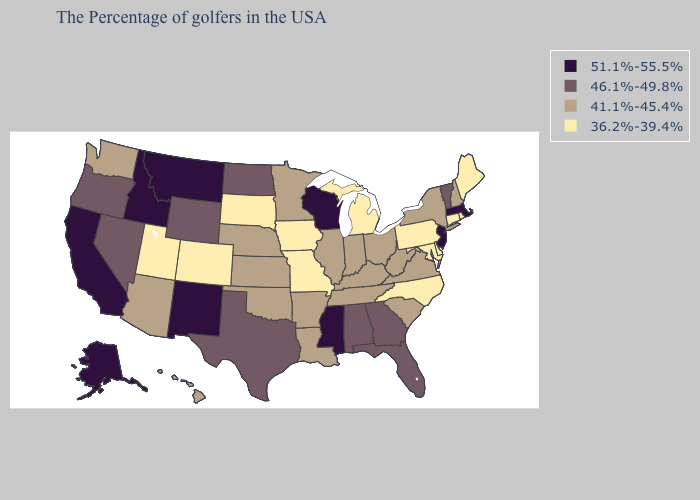What is the highest value in the South ?
Answer briefly. 51.1%-55.5%. Which states hav the highest value in the West?
Answer briefly. New Mexico, Montana, Idaho, California, Alaska. What is the highest value in the USA?
Quick response, please. 51.1%-55.5%. Name the states that have a value in the range 46.1%-49.8%?
Write a very short answer. Vermont, Florida, Georgia, Alabama, Texas, North Dakota, Wyoming, Nevada, Oregon. Which states have the lowest value in the USA?
Be succinct. Maine, Rhode Island, Connecticut, Delaware, Maryland, Pennsylvania, North Carolina, Michigan, Missouri, Iowa, South Dakota, Colorado, Utah. Does Kansas have a higher value than Texas?
Concise answer only. No. Name the states that have a value in the range 46.1%-49.8%?
Answer briefly. Vermont, Florida, Georgia, Alabama, Texas, North Dakota, Wyoming, Nevada, Oregon. Does Oregon have a higher value than New Mexico?
Be succinct. No. What is the highest value in the West ?
Concise answer only. 51.1%-55.5%. What is the highest value in the USA?
Answer briefly. 51.1%-55.5%. Among the states that border South Dakota , does Minnesota have the lowest value?
Answer briefly. No. Name the states that have a value in the range 51.1%-55.5%?
Write a very short answer. Massachusetts, New Jersey, Wisconsin, Mississippi, New Mexico, Montana, Idaho, California, Alaska. What is the highest value in states that border New York?
Give a very brief answer. 51.1%-55.5%. How many symbols are there in the legend?
Concise answer only. 4. 